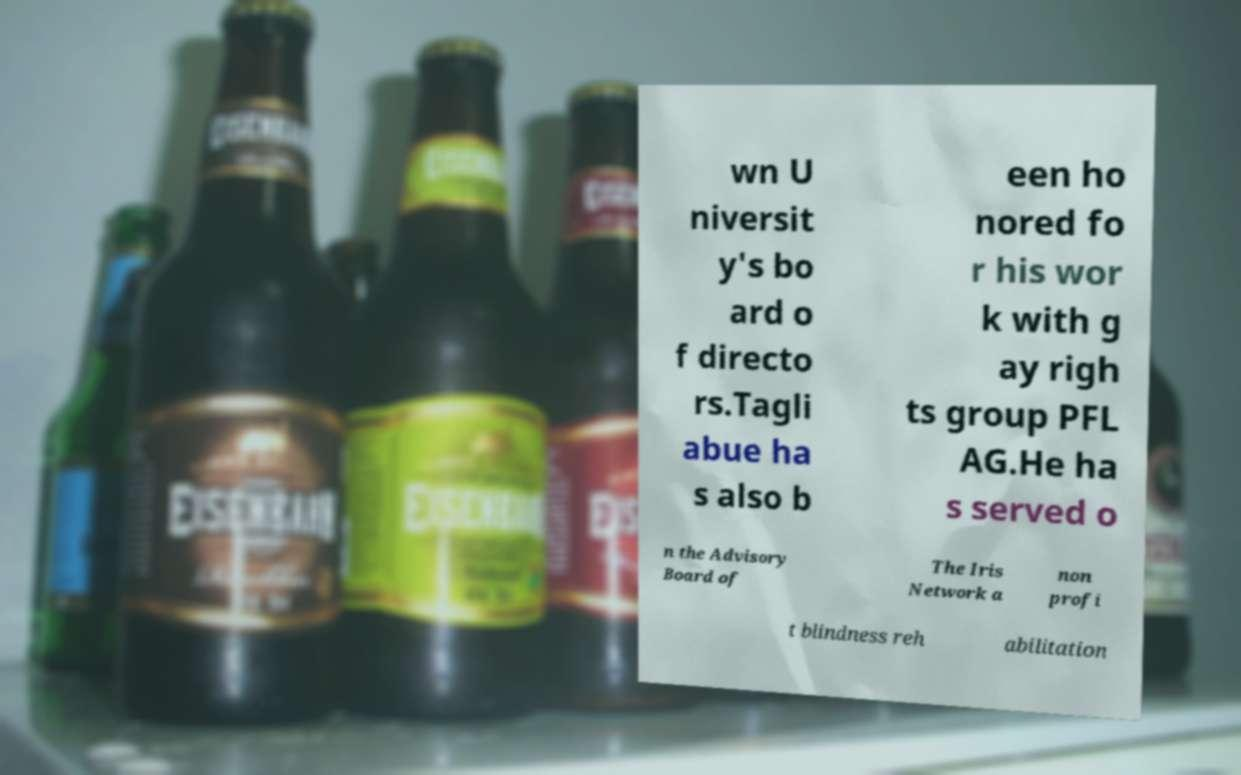Please read and relay the text visible in this image. What does it say? wn U niversit y's bo ard o f directo rs.Tagli abue ha s also b een ho nored fo r his wor k with g ay righ ts group PFL AG.He ha s served o n the Advisory Board of The Iris Network a non profi t blindness reh abilitation 